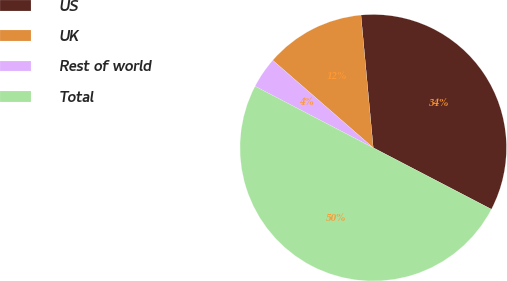<chart> <loc_0><loc_0><loc_500><loc_500><pie_chart><fcel>US<fcel>UK<fcel>Rest of world<fcel>Total<nl><fcel>34.11%<fcel>12.13%<fcel>3.76%<fcel>50.0%<nl></chart> 